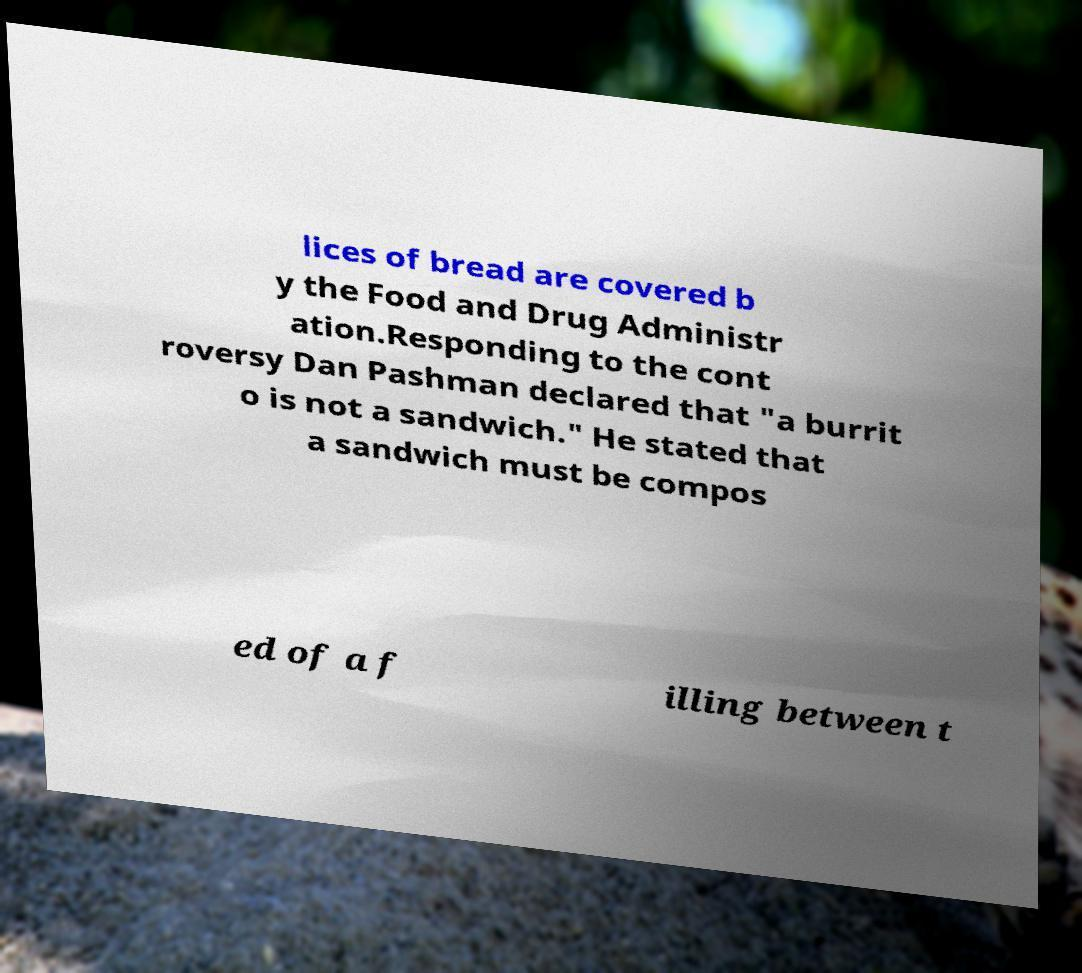What messages or text are displayed in this image? I need them in a readable, typed format. lices of bread are covered b y the Food and Drug Administr ation.Responding to the cont roversy Dan Pashman declared that "a burrit o is not a sandwich." He stated that a sandwich must be compos ed of a f illing between t 